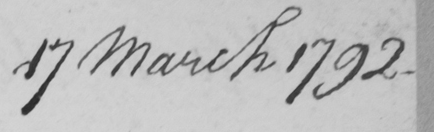Please transcribe the handwritten text in this image. 17 March 1792 . 